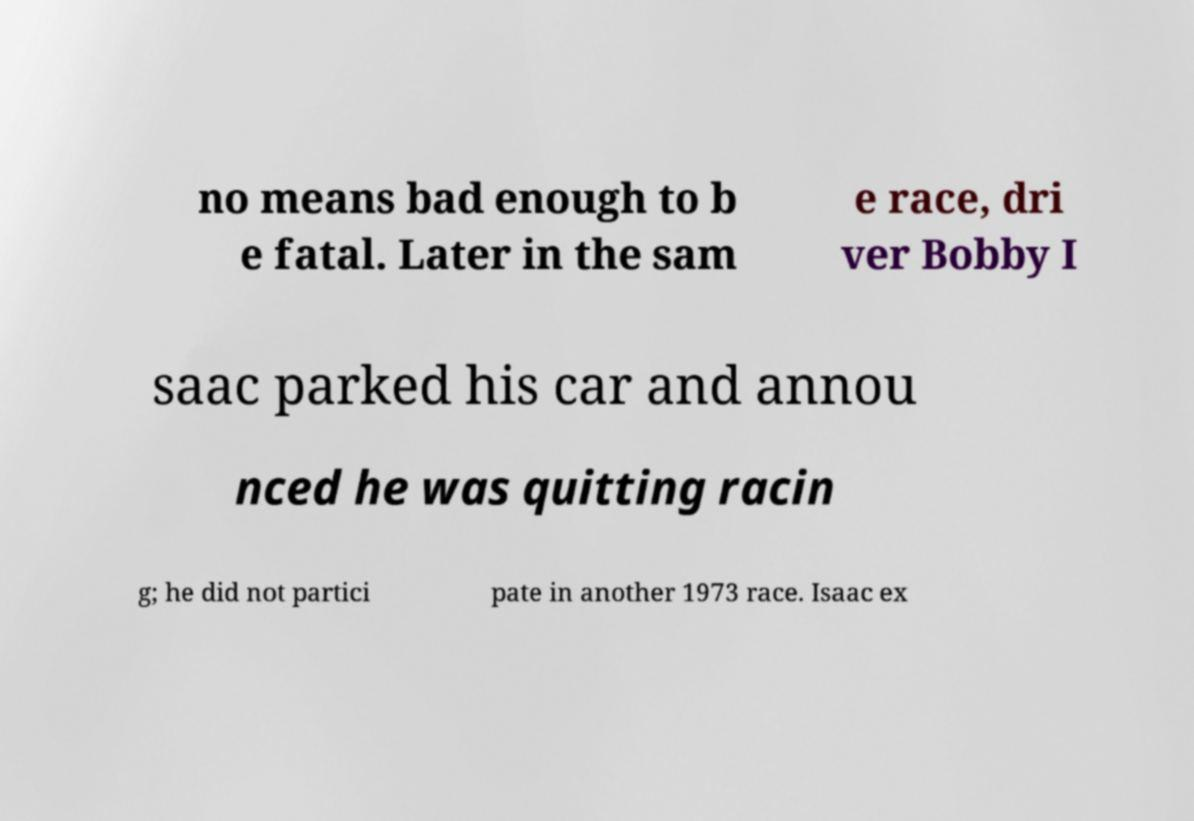Can you accurately transcribe the text from the provided image for me? no means bad enough to b e fatal. Later in the sam e race, dri ver Bobby I saac parked his car and annou nced he was quitting racin g; he did not partici pate in another 1973 race. Isaac ex 